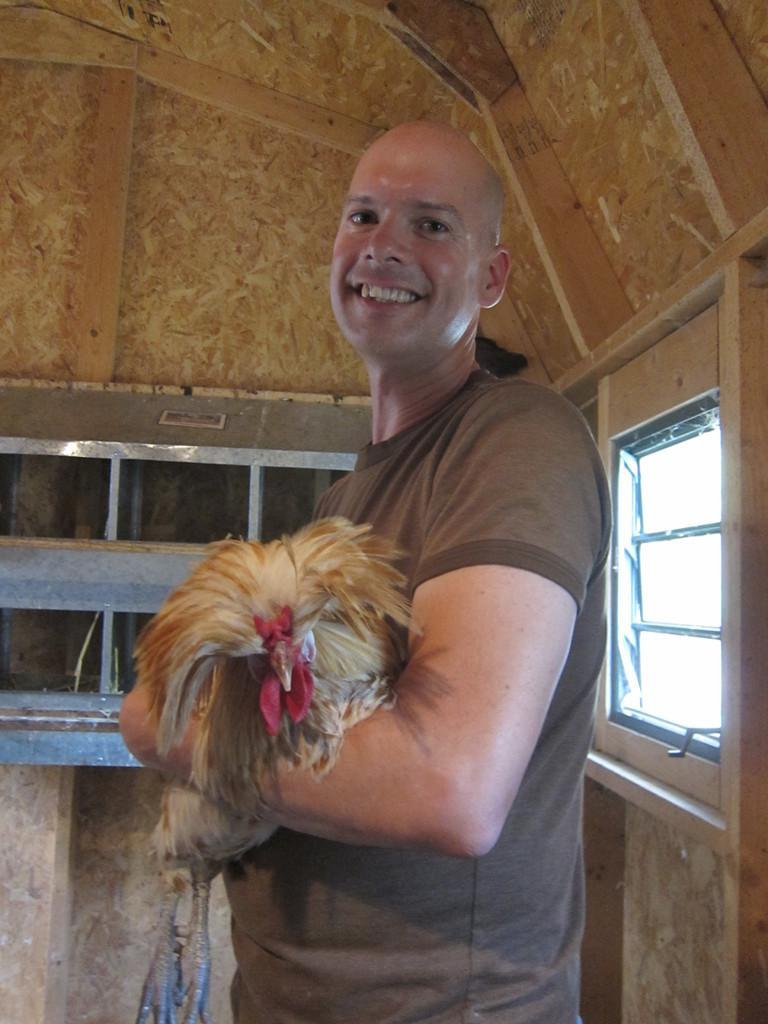Can you describe this image briefly? In this image I can see a person holding the bird. The bird is in brown and red color. Back I can see a wooden wall and window. 